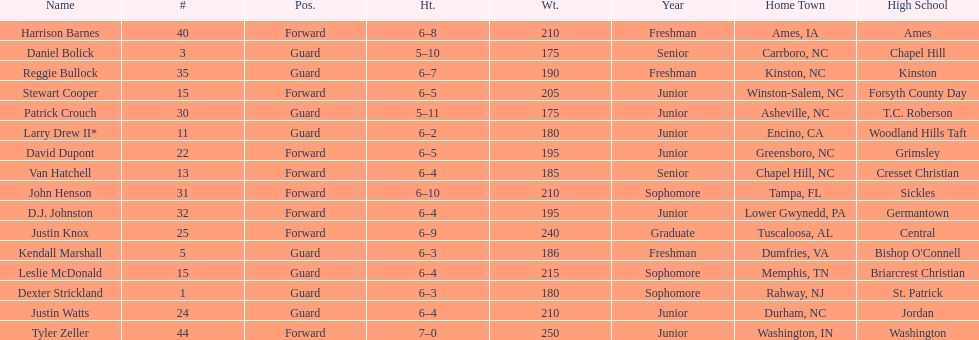Names of players who were exactly 6 feet, 4 inches tall, but did not weight over 200 pounds Van Hatchell, D.J. Johnston. 